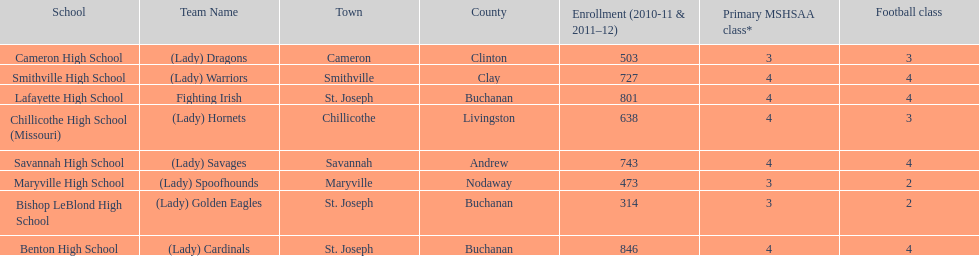What is the number of football classes lafayette high school has? 4. Would you be able to parse every entry in this table? {'header': ['School', 'Team Name', 'Town', 'County', 'Enrollment (2010-11 & 2011–12)', 'Primary MSHSAA class*', 'Football class'], 'rows': [['Cameron High School', '(Lady) Dragons', 'Cameron', 'Clinton', '503', '3', '3'], ['Smithville High School', '(Lady) Warriors', 'Smithville', 'Clay', '727', '4', '4'], ['Lafayette High School', 'Fighting Irish', 'St. Joseph', 'Buchanan', '801', '4', '4'], ['Chillicothe High School (Missouri)', '(Lady) Hornets', 'Chillicothe', 'Livingston', '638', '4', '3'], ['Savannah High School', '(Lady) Savages', 'Savannah', 'Andrew', '743', '4', '4'], ['Maryville High School', '(Lady) Spoofhounds', 'Maryville', 'Nodaway', '473', '3', '2'], ['Bishop LeBlond High School', '(Lady) Golden Eagles', 'St. Joseph', 'Buchanan', '314', '3', '2'], ['Benton High School', '(Lady) Cardinals', 'St. Joseph', 'Buchanan', '846', '4', '4']]} 